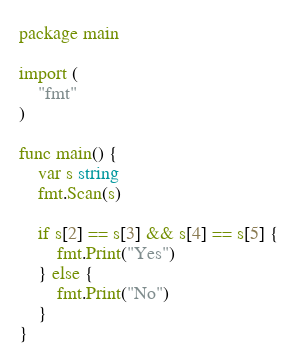Convert code to text. <code><loc_0><loc_0><loc_500><loc_500><_Go_>package main

import (
	"fmt"
)

func main() {
	var s string
	fmt.Scan(s)

	if s[2] == s[3] && s[4] == s[5] {
		fmt.Print("Yes")
	} else {
		fmt.Print("No")
	}
}
</code> 